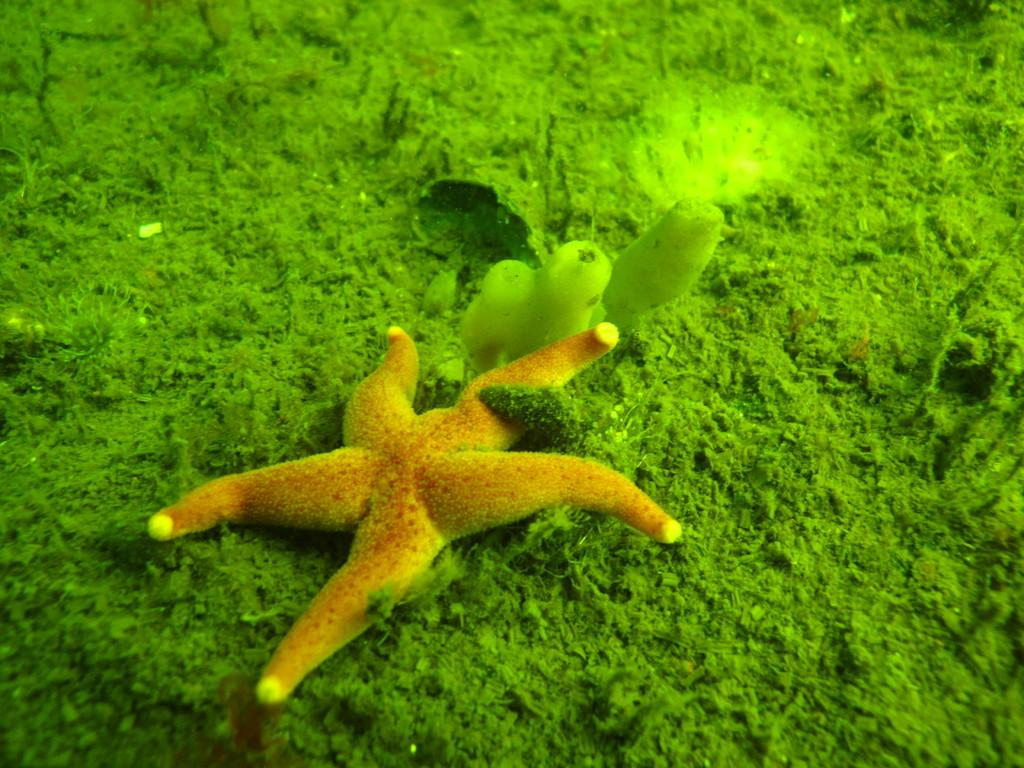What is the main subject in the center of the image? There is a starfish in the center of the image. Are there any other objects or elements in the image besides the starfish? Yes, there are other objects in the image. What can be observed about the background of the image? The background of the image is green, which appears to be grass. How does the minister interact with the knot in the image? There is no minister or knot present in the image; it features a starfish and other unspecified objects. 